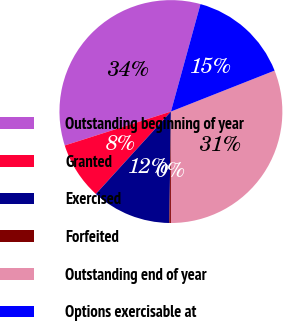Convert chart. <chart><loc_0><loc_0><loc_500><loc_500><pie_chart><fcel>Outstanding beginning of year<fcel>Granted<fcel>Exercised<fcel>Forfeited<fcel>Outstanding end of year<fcel>Options exercisable at<nl><fcel>34.2%<fcel>8.32%<fcel>11.53%<fcel>0.23%<fcel>30.99%<fcel>14.74%<nl></chart> 